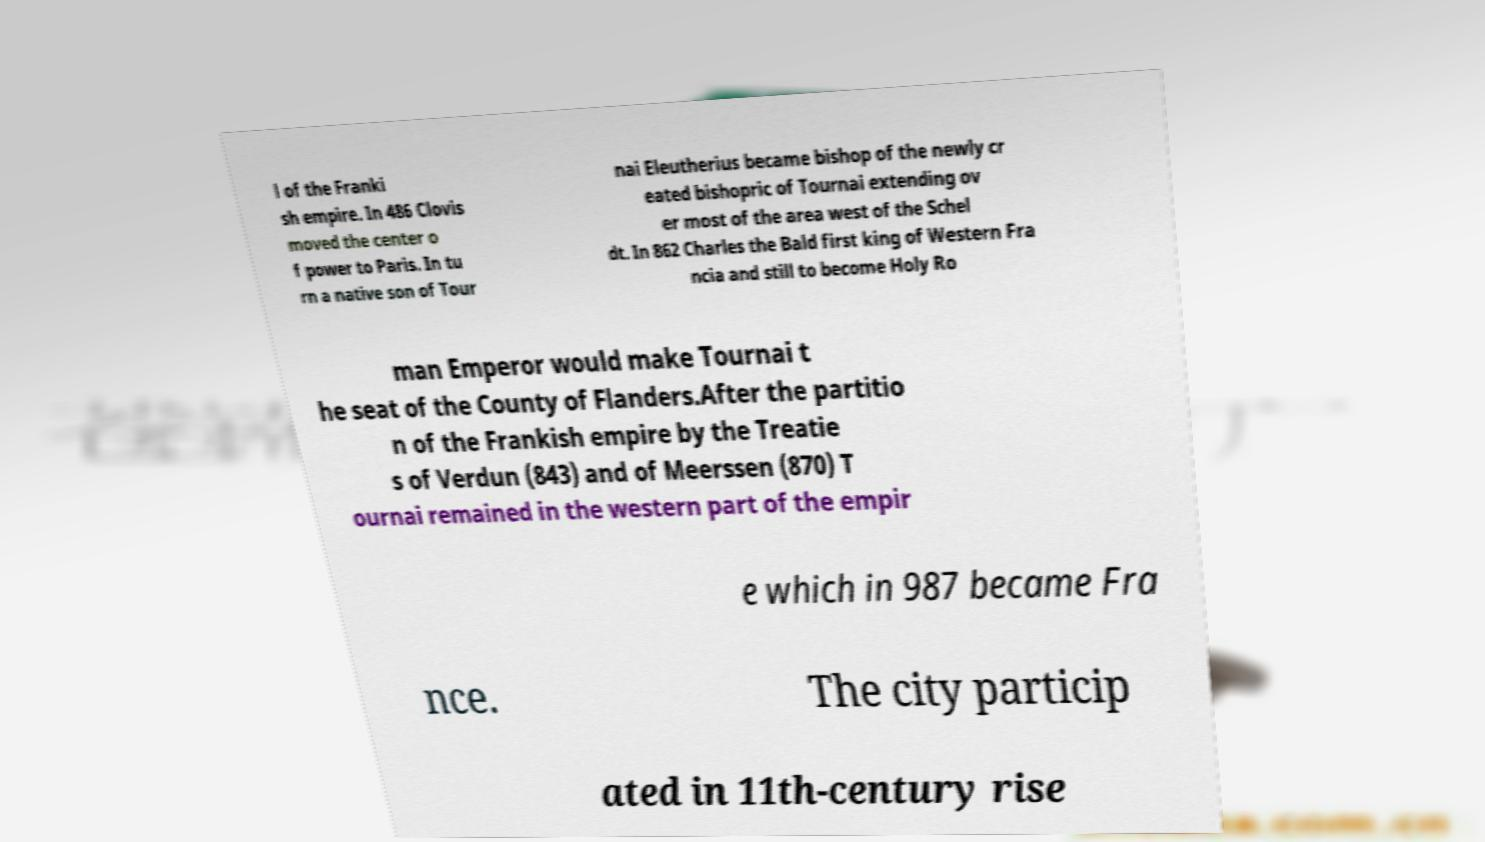I need the written content from this picture converted into text. Can you do that? l of the Franki sh empire. In 486 Clovis moved the center o f power to Paris. In tu rn a native son of Tour nai Eleutherius became bishop of the newly cr eated bishopric of Tournai extending ov er most of the area west of the Schel dt. In 862 Charles the Bald first king of Western Fra ncia and still to become Holy Ro man Emperor would make Tournai t he seat of the County of Flanders.After the partitio n of the Frankish empire by the Treatie s of Verdun (843) and of Meerssen (870) T ournai remained in the western part of the empir e which in 987 became Fra nce. The city particip ated in 11th-century rise 